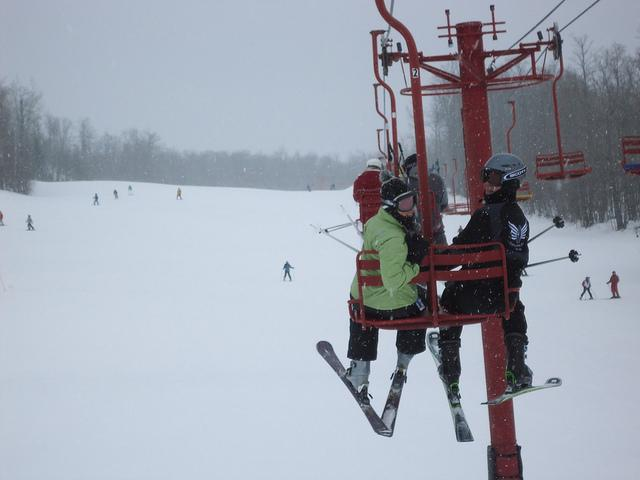Why are they so high up? ski lift 